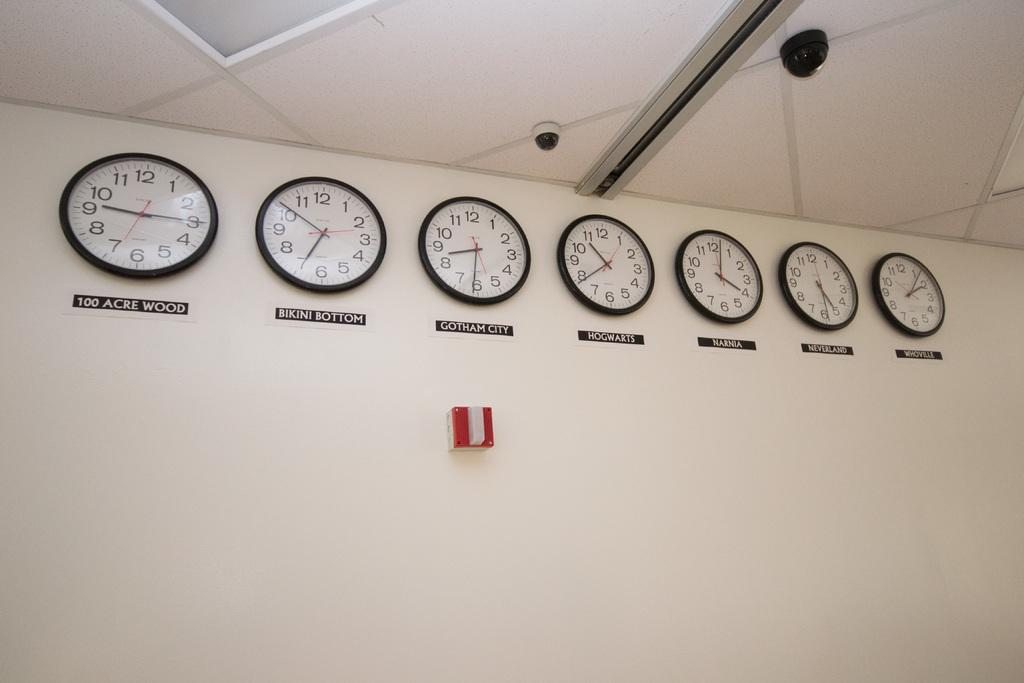<image>
Offer a succinct explanation of the picture presented. Several clocks on a white wall; the one on the far left reads 100 Acre Wood. 